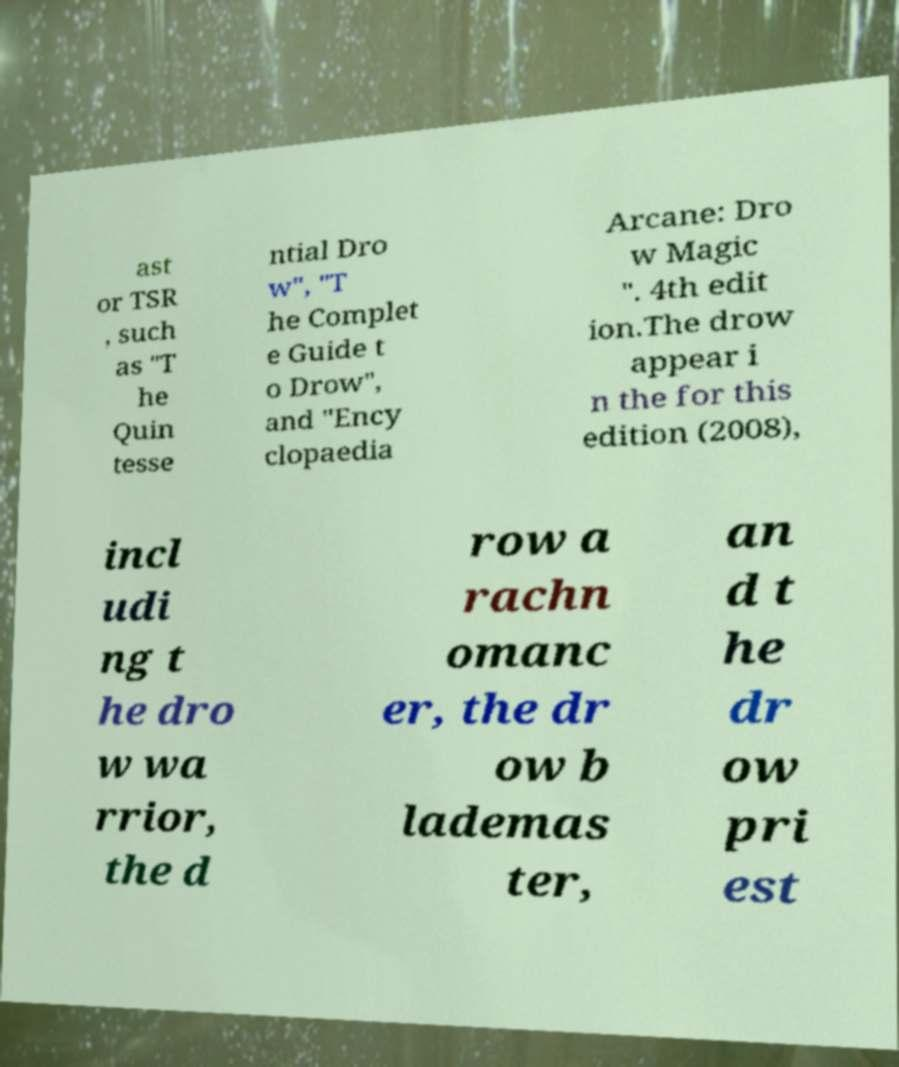Could you extract and type out the text from this image? ast or TSR , such as "T he Quin tesse ntial Dro w", "T he Complet e Guide t o Drow", and "Ency clopaedia Arcane: Dro w Magic ". 4th edit ion.The drow appear i n the for this edition (2008), incl udi ng t he dro w wa rrior, the d row a rachn omanc er, the dr ow b lademas ter, an d t he dr ow pri est 